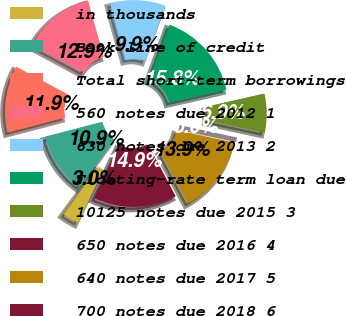<chart> <loc_0><loc_0><loc_500><loc_500><pie_chart><fcel>in thousands<fcel>Bank line of credit<fcel>Total short-term borrowings<fcel>560 notes due 2012 1<fcel>630 notes due 2013 2<fcel>Floating-rate term loan due<fcel>10125 notes due 2015 3<fcel>650 notes due 2016 4<fcel>640 notes due 2017 5<fcel>700 notes due 2018 6<nl><fcel>2.97%<fcel>10.89%<fcel>11.88%<fcel>12.87%<fcel>9.9%<fcel>15.84%<fcel>6.93%<fcel>0.0%<fcel>13.86%<fcel>14.85%<nl></chart> 